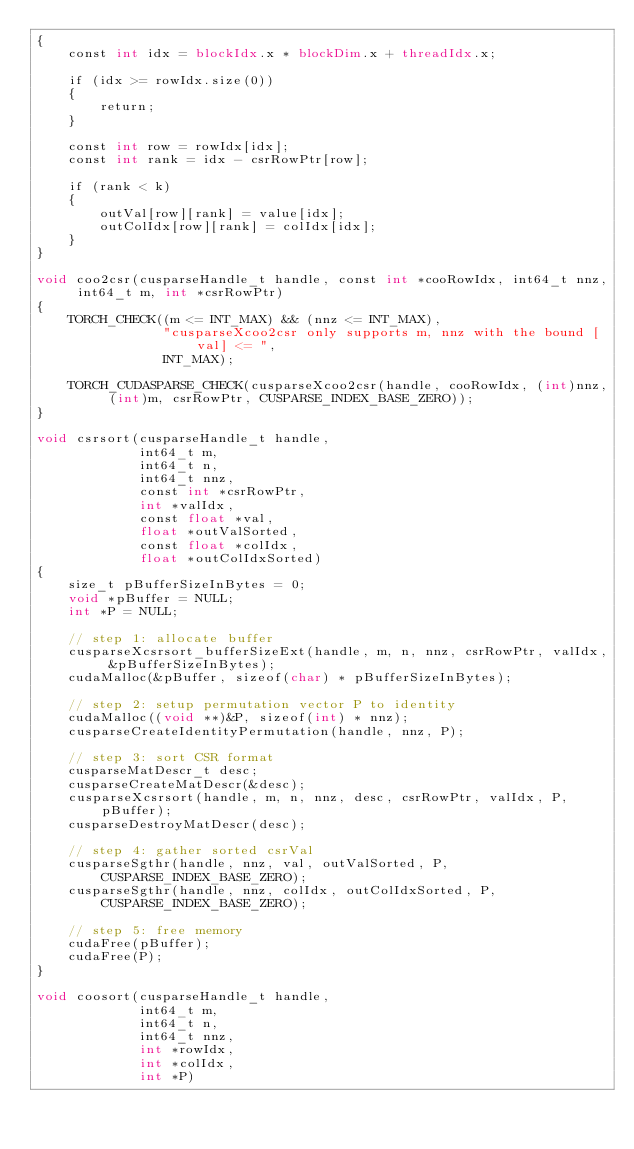Convert code to text. <code><loc_0><loc_0><loc_500><loc_500><_Cuda_>{
    const int idx = blockIdx.x * blockDim.x + threadIdx.x;

    if (idx >= rowIdx.size(0))
    {
        return;
    }

    const int row = rowIdx[idx];
    const int rank = idx - csrRowPtr[row];

    if (rank < k)
    {
        outVal[row][rank] = value[idx];
        outColIdx[row][rank] = colIdx[idx];
    }
}

void coo2csr(cusparseHandle_t handle, const int *cooRowIdx, int64_t nnz, int64_t m, int *csrRowPtr)
{
    TORCH_CHECK((m <= INT_MAX) && (nnz <= INT_MAX),
                "cusparseXcoo2csr only supports m, nnz with the bound [val] <= ",
                INT_MAX);

    TORCH_CUDASPARSE_CHECK(cusparseXcoo2csr(handle, cooRowIdx, (int)nnz, (int)m, csrRowPtr, CUSPARSE_INDEX_BASE_ZERO));
}

void csrsort(cusparseHandle_t handle,
             int64_t m,
             int64_t n,
             int64_t nnz,
             const int *csrRowPtr,
             int *valIdx,
             const float *val,
             float *outValSorted,
             const float *colIdx,
             float *outColIdxSorted)
{
    size_t pBufferSizeInBytes = 0;
    void *pBuffer = NULL;
    int *P = NULL;

    // step 1: allocate buffer
    cusparseXcsrsort_bufferSizeExt(handle, m, n, nnz, csrRowPtr, valIdx, &pBufferSizeInBytes);
    cudaMalloc(&pBuffer, sizeof(char) * pBufferSizeInBytes);

    // step 2: setup permutation vector P to identity
    cudaMalloc((void **)&P, sizeof(int) * nnz);
    cusparseCreateIdentityPermutation(handle, nnz, P);

    // step 3: sort CSR format
    cusparseMatDescr_t desc;
    cusparseCreateMatDescr(&desc);
    cusparseXcsrsort(handle, m, n, nnz, desc, csrRowPtr, valIdx, P, pBuffer);
    cusparseDestroyMatDescr(desc);

    // step 4: gather sorted csrVal
    cusparseSgthr(handle, nnz, val, outValSorted, P, CUSPARSE_INDEX_BASE_ZERO);
    cusparseSgthr(handle, nnz, colIdx, outColIdxSorted, P, CUSPARSE_INDEX_BASE_ZERO);

    // step 5: free memory
    cudaFree(pBuffer);
    cudaFree(P);
}

void coosort(cusparseHandle_t handle,
             int64_t m,
             int64_t n,
             int64_t nnz,
             int *rowIdx,
             int *colIdx,
             int *P)</code> 